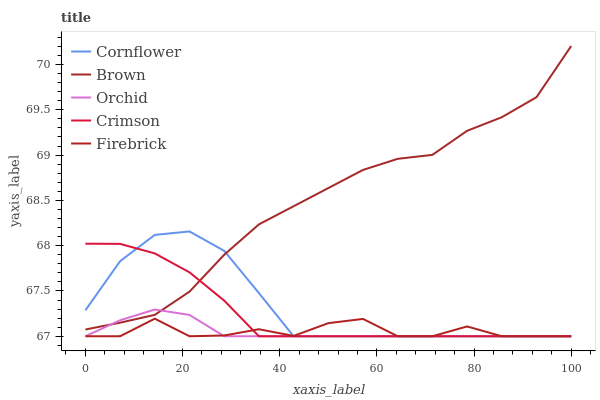Does Cornflower have the minimum area under the curve?
Answer yes or no. No. Does Cornflower have the maximum area under the curve?
Answer yes or no. No. Is Cornflower the smoothest?
Answer yes or no. No. Is Cornflower the roughest?
Answer yes or no. No. Does Brown have the lowest value?
Answer yes or no. No. Does Cornflower have the highest value?
Answer yes or no. No. Is Firebrick less than Brown?
Answer yes or no. Yes. Is Brown greater than Firebrick?
Answer yes or no. Yes. Does Firebrick intersect Brown?
Answer yes or no. No. 